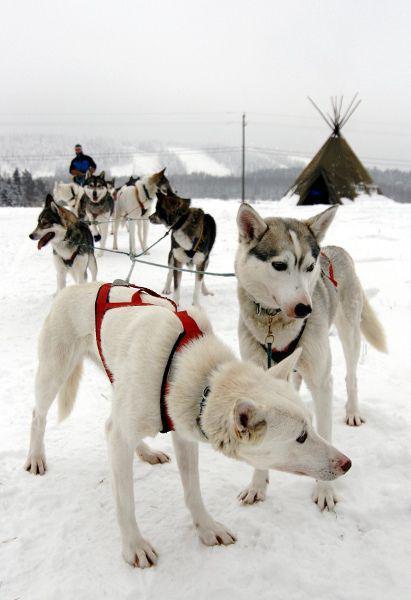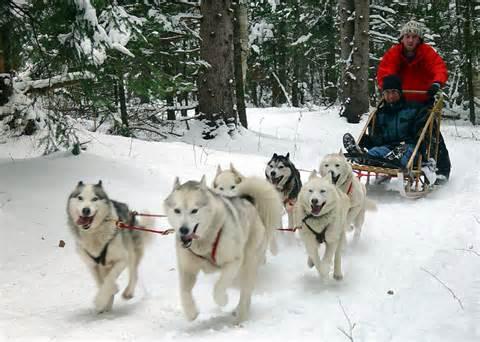The first image is the image on the left, the second image is the image on the right. Assess this claim about the two images: "the right image has humans in red jackets". Correct or not? Answer yes or no. Yes. The first image is the image on the left, the second image is the image on the right. Considering the images on both sides, is "There are at least two people riding on one of the dog sleds." valid? Answer yes or no. Yes. 